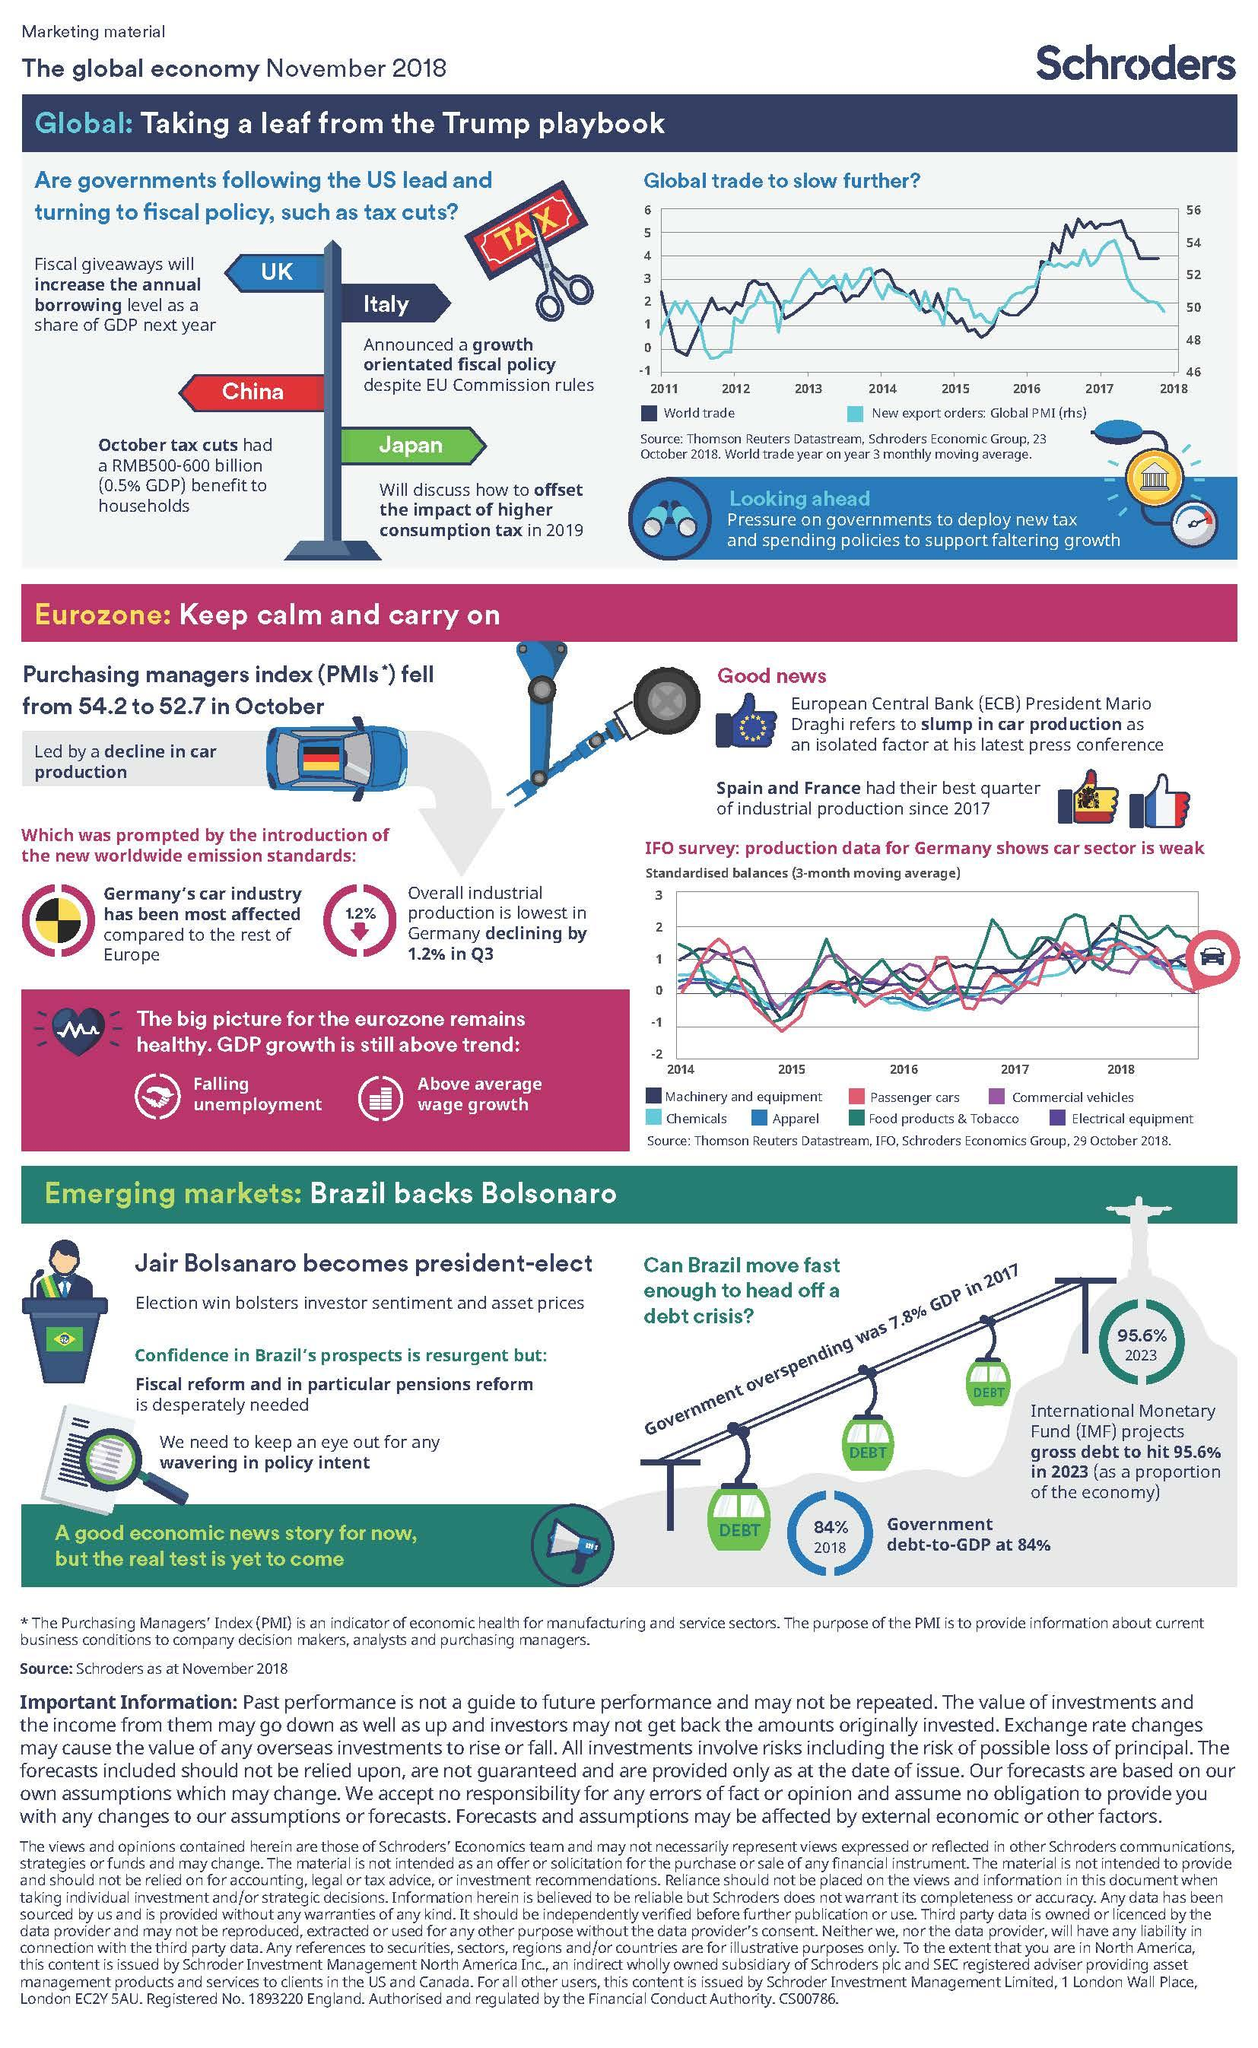Highlight a few significant elements in this photo. Despite the success of fiscal policy initiatives in the United States, a growing number of countries are following suit and implementing similar tax cuts. The color blue represents the apparel industry in the graph. In 2018, the commercial vehicles production sector showed the weakest growth when compared to other production sectors, including passenger cars. In 2018, the production industry that showed the highest growth was that of food products and tobacco. 